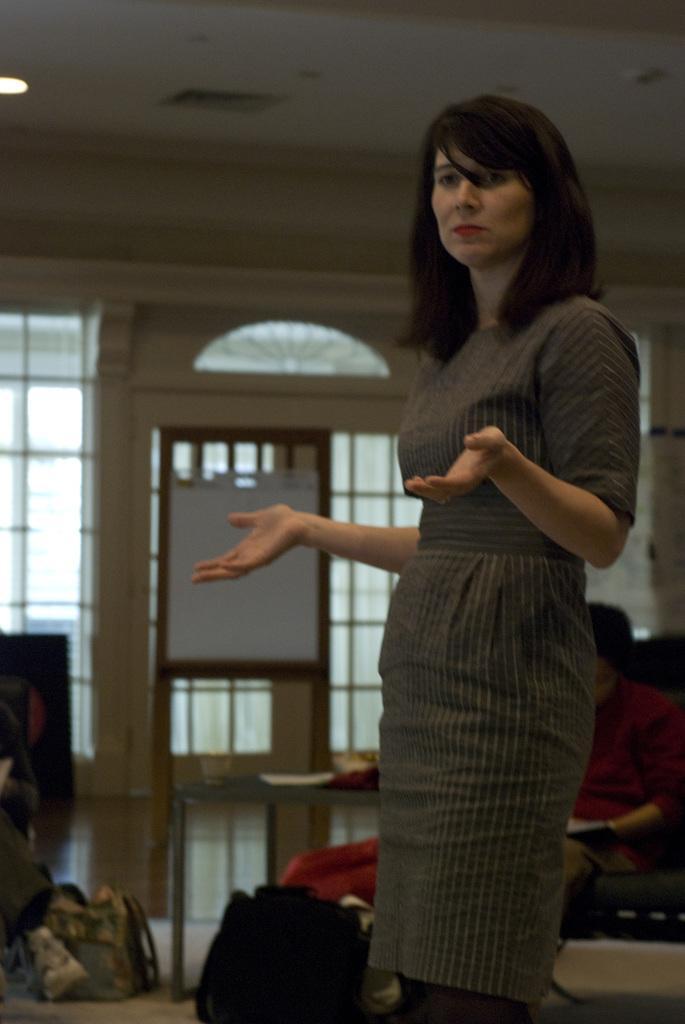In one or two sentences, can you explain what this image depicts? In this image we can see a woman with long hair wearing a dress is standing on the floor. In the background, we can see a table, group of bags placed on the floor, a person sitting on the chair and windows. 